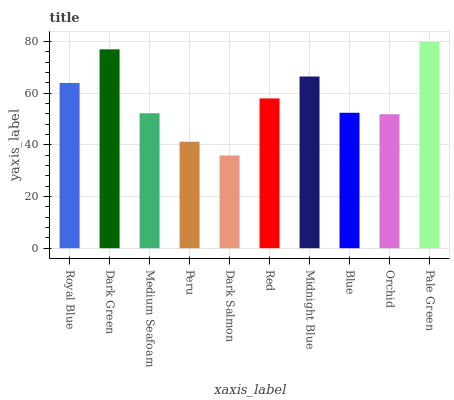Is Dark Green the minimum?
Answer yes or no. No. Is Dark Green the maximum?
Answer yes or no. No. Is Dark Green greater than Royal Blue?
Answer yes or no. Yes. Is Royal Blue less than Dark Green?
Answer yes or no. Yes. Is Royal Blue greater than Dark Green?
Answer yes or no. No. Is Dark Green less than Royal Blue?
Answer yes or no. No. Is Red the high median?
Answer yes or no. Yes. Is Blue the low median?
Answer yes or no. Yes. Is Blue the high median?
Answer yes or no. No. Is Dark Green the low median?
Answer yes or no. No. 